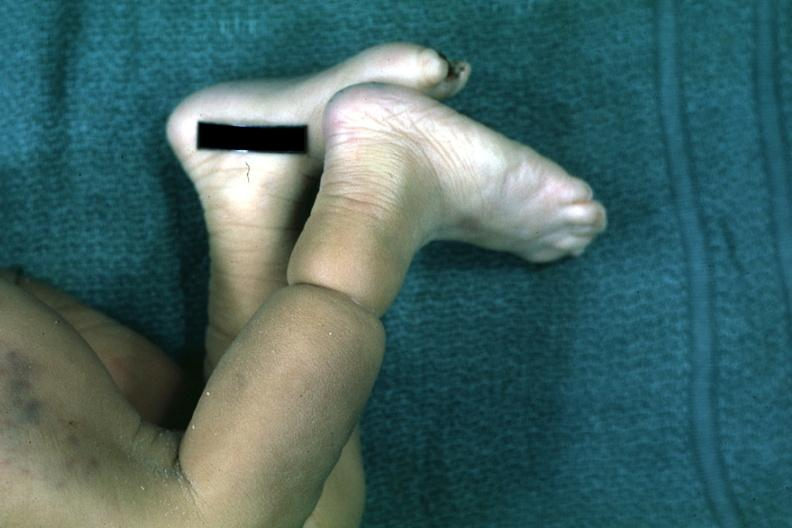does thyroid show called streeters band whatever that is looks like an amniotic band lesion?
Answer the question using a single word or phrase. No 